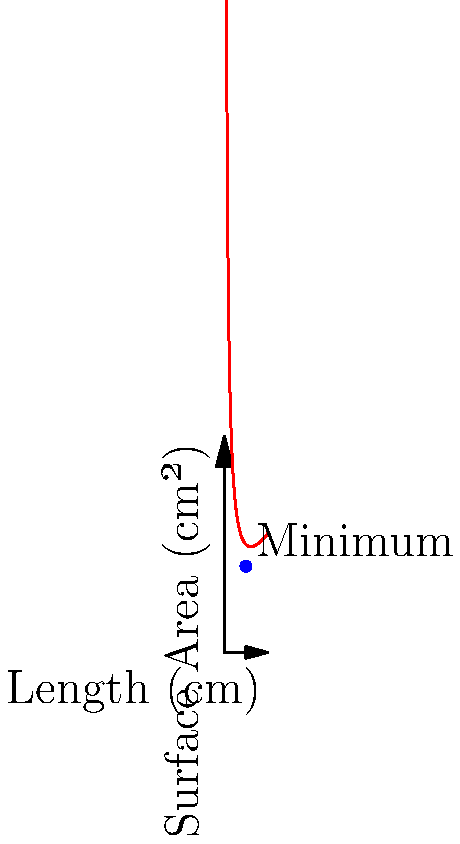As a small-scale manufacturer committed to minimizing material waste, you need to design a cylindrical container with a volume of 3000 cm³. The surface area (S) of the cylinder is given by the formula $S = 2\pi r^2 + 2\pi rh$, where r is the radius and h is the height. If the length (L) of the cylinder is defined as $L = 2r + h$, express the surface area S as a function of r, and determine the optimal radius that minimizes the surface area. Round your answer to the nearest centimeter. 1) First, we need to express h in terms of r:
   Volume = $\pi r^2h = 3000$
   $h = \frac{3000}{\pi r^2}$

2) Now, we can express L in terms of r:
   $L = 2r + \frac{3000}{\pi r^2}$

3) The surface area S can be written as:
   $S = 2\pi r^2 + 2\pi r(\frac{3000}{\pi r^2})$
   $S = 2\pi r^2 + \frac{6000}{r}$

4) To find the minimum, we differentiate S with respect to r and set it to zero:
   $\frac{dS}{dr} = 4\pi r - \frac{6000}{r^2} = 0$

5) Solving this equation:
   $4\pi r^3 = 6000$
   $r^3 = \frac{6000}{4\pi} \approx 477.5$
   $r \approx 7.8$ cm

6) The optimal radius is approximately 8 cm (rounded to the nearest cm).

7) To verify this is a minimum, we can check the second derivative is positive at this point.
Answer: 8 cm 